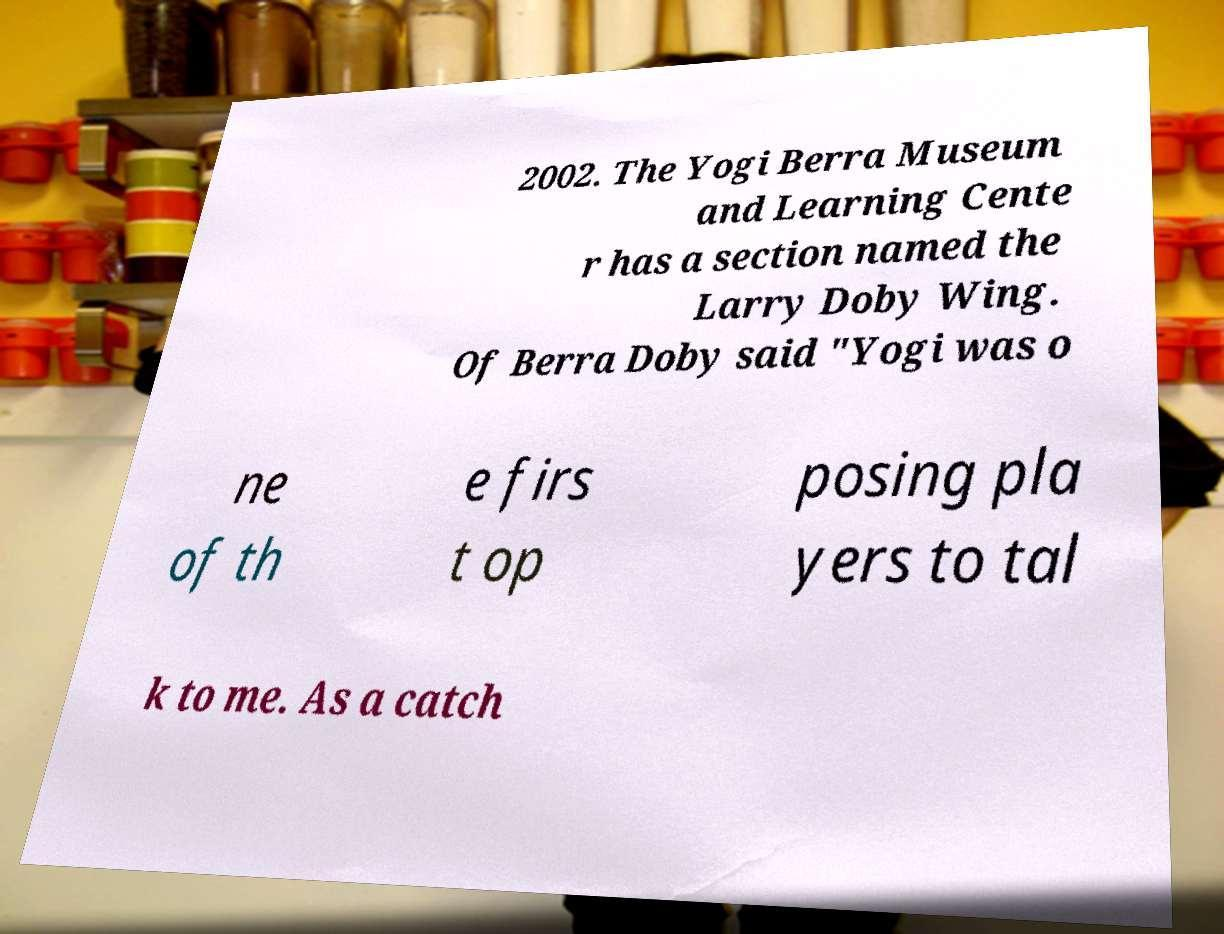Could you extract and type out the text from this image? 2002. The Yogi Berra Museum and Learning Cente r has a section named the Larry Doby Wing. Of Berra Doby said "Yogi was o ne of th e firs t op posing pla yers to tal k to me. As a catch 